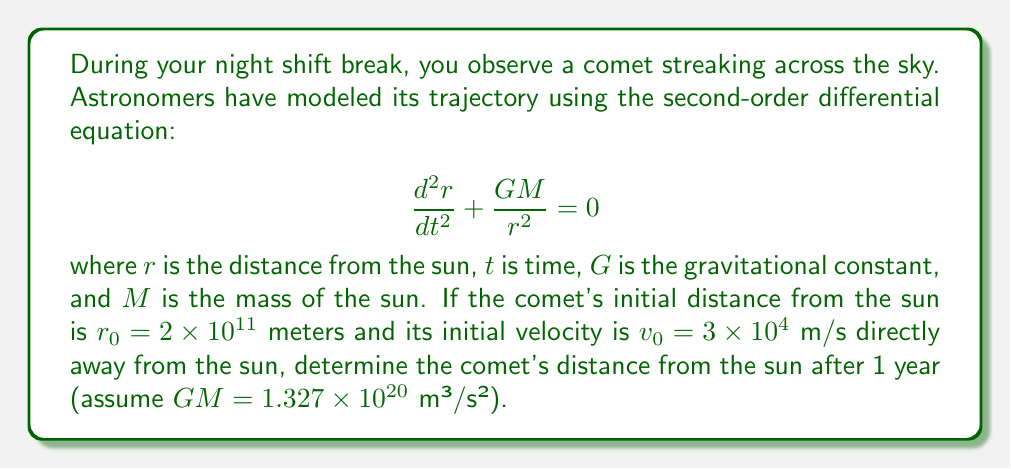Give your solution to this math problem. To solve this problem, we need to use the energy conservation principle, as the second-order differential equation doesn't have a simple analytical solution.

1) The total energy of the comet remains constant throughout its orbit. This energy is the sum of kinetic and potential energy:

   $$E = \frac{1}{2}mv^2 - \frac{GMm}{r} = \text{constant}$$

2) At any point in the orbit, including the initial position and the position after 1 year:

   $$\frac{1}{2}mv_0^2 - \frac{GMm}{r_0} = \frac{1}{2}mv^2 - \frac{GMm}{r}$$

3) Simplify by canceling out $m$ on both sides:

   $$\frac{1}{2}v_0^2 - \frac{GM}{r_0} = \frac{1}{2}v^2 - \frac{GM}{r}$$

4) We know $v_0$, $r_0$, and $GM$. We want to find $r$ after 1 year. At this point, we don't know $v$, but we can use the fact that angular momentum is conserved:

   $$r_0v_0 = rv$$

5) Solve for $v$:

   $$v = \frac{r_0v_0}{r}$$

6) Substitute this into the energy equation:

   $$\frac{1}{2}v_0^2 - \frac{GM}{r_0} = \frac{1}{2}\left(\frac{r_0v_0}{r}\right)^2 - \frac{GM}{r}$$

7) Multiply both sides by $2r^2$:

   $$r^2v_0^2 - \frac{2GMr}{r_0} = r_0^2v_0^2 - 2GMr$$

8) Rearrange:

   $$r^2v_0^2 - r_0^2v_0^2 = \frac{2GMr}{r_0} - 2GMr = 2GMr\left(\frac{1}{r_0} - 1\right)$$

9) Solve for $r$:

   $$r = \frac{r_0^2v_0^2}{2GM\left(\frac{1}{r_0} - 1\right) + v_0^2}$$

10) Now we can plug in the values:
    $r_0 = 2 \times 10^{11}$ m
    $v_0 = 3 \times 10^4$ m/s
    $GM = 1.327 \times 10^{20}$ m³/s²

11) Calculating:

    $$r = \frac{(2 \times 10^{11})^2(3 \times 10^4)^2}{2(1.327 \times 10^{20})(\frac{1}{2 \times 10^{11}} - 1) + (3 \times 10^4)^2}$$

12) This evaluates to approximately $2.67 \times 10^{11}$ meters.
Answer: The comet's distance from the sun after 1 year is approximately $2.67 \times 10^{11}$ meters. 